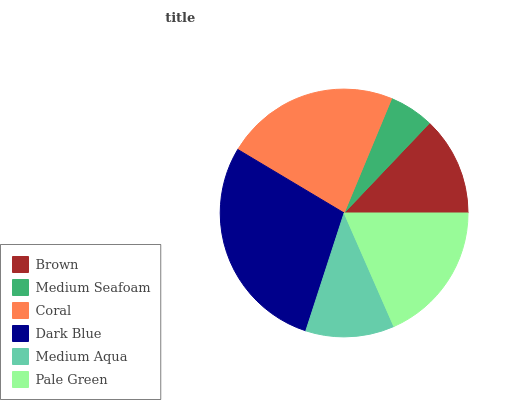Is Medium Seafoam the minimum?
Answer yes or no. Yes. Is Dark Blue the maximum?
Answer yes or no. Yes. Is Coral the minimum?
Answer yes or no. No. Is Coral the maximum?
Answer yes or no. No. Is Coral greater than Medium Seafoam?
Answer yes or no. Yes. Is Medium Seafoam less than Coral?
Answer yes or no. Yes. Is Medium Seafoam greater than Coral?
Answer yes or no. No. Is Coral less than Medium Seafoam?
Answer yes or no. No. Is Pale Green the high median?
Answer yes or no. Yes. Is Brown the low median?
Answer yes or no. Yes. Is Medium Seafoam the high median?
Answer yes or no. No. Is Dark Blue the low median?
Answer yes or no. No. 